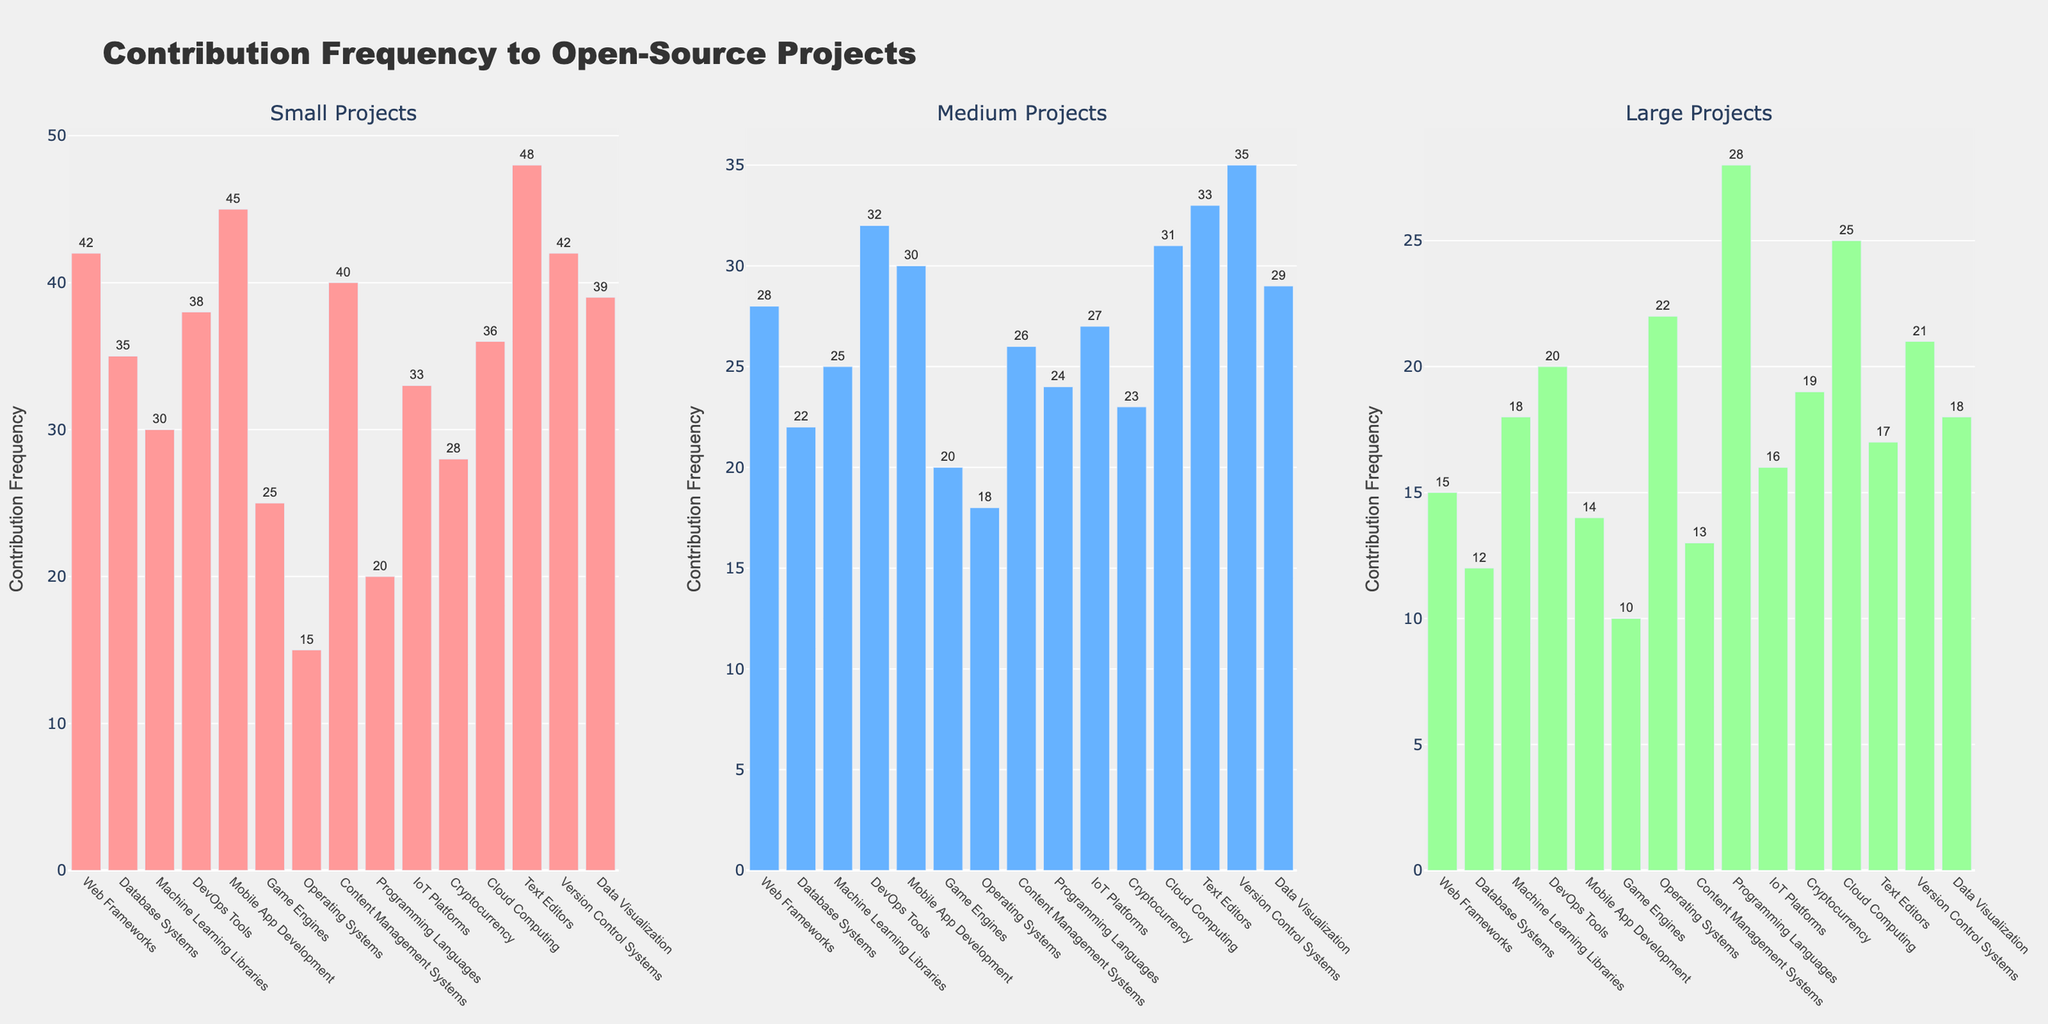Which project type has the highest contribution frequency in small projects? Look at the "Small Projects" column in the bar chart. The bar that reaches the highest value represents the highest contribution frequency. The "Text Editors" bar is the tallest, with a contribution frequency of 48.
Answer: Text Editors Which project type has the highest contribution frequency in large projects? Look at the "Large Projects" column in the bar chart. The bar that reaches the highest value represents the highest contribution frequency. The "Programming Languages" bar is the tallest, with a contribution frequency of 28.
Answer: Programming Languages Which project type has a higher contribution frequency for small projects compared to large projects? Compare the heights of the bars between the "Small Projects" and "Large Projects" columns. Some examples include "Web Frameworks" (42 in Small vs. 15 in Large) and "Mobile App Development" (45 in Small vs. 14 in Large). Several project types fit this condition.
Answer: Web Frameworks, Mobile App Development (among others) Which project type shows an increasing trend from small to medium to large projects? Look for the bars that progressively get taller as you move from "Small Projects" to "Medium Projects" to "Large Projects". The "Operating Systems" category shows this trend (15, 18, 22).
Answer: Operating Systems What is the difference in contribution frequency between small and medium projects for DevOps Tools? Look at the "DevOps Tools" row in the "Small Projects" (38) and "Medium Projects" (32) columns and find the difference: 38 - 32 = 6.
Answer: 6 Calculate the average contribution frequency across all project types for large projects. Sum the contribution frequencies in the "Large Projects" column and divide by the number of project types: (15+12+18+20+14+10+22+13+28+16+19+25+17+21+18) = 258. Then divide 258 by 15 (number of project types) which equals 17.2.
Answer: 17.2 Which project type has the lowest contribution frequency in medium projects? Look at the "Medium Projects" column and identify the bar that is the shortest. The "Operating Systems" bar has the lowest value of 18.
Answer: Operating Systems How many project types have a contribution frequency greater than 30 for small projects? Count the number of bars in the "Small Projects" column that are taller than 30. The project types are "Web Frameworks" (42), "Mobile App Development" (45), "Content Management Systems" (40), "Text Editors" (48), "Version Control Systems" (42), and "Cloud Computing" (36), totaling 6.
Answer: 6 What is the combined contribution frequency for small projects in "Web Frameworks" and "Database Systems"? Sum the contribution frequencies of "Web Frameworks" (42) and "Database Systems" (35) from the "Small Projects" column: 42 + 35 = 77.
Answer: 77 Which project type exhibits the largest difference in contribution frequency between medium and large projects? Look at the differences between the "Medium Projects" and "Large Projects" columns for each project type. "Cloud Computing" shows a difference of 31 - 25 = 6, "Text Editors" have a difference of 33 - 17 = 16, and so on. The largest difference appears for "Text Editors" with 16.
Answer: Text Editors 